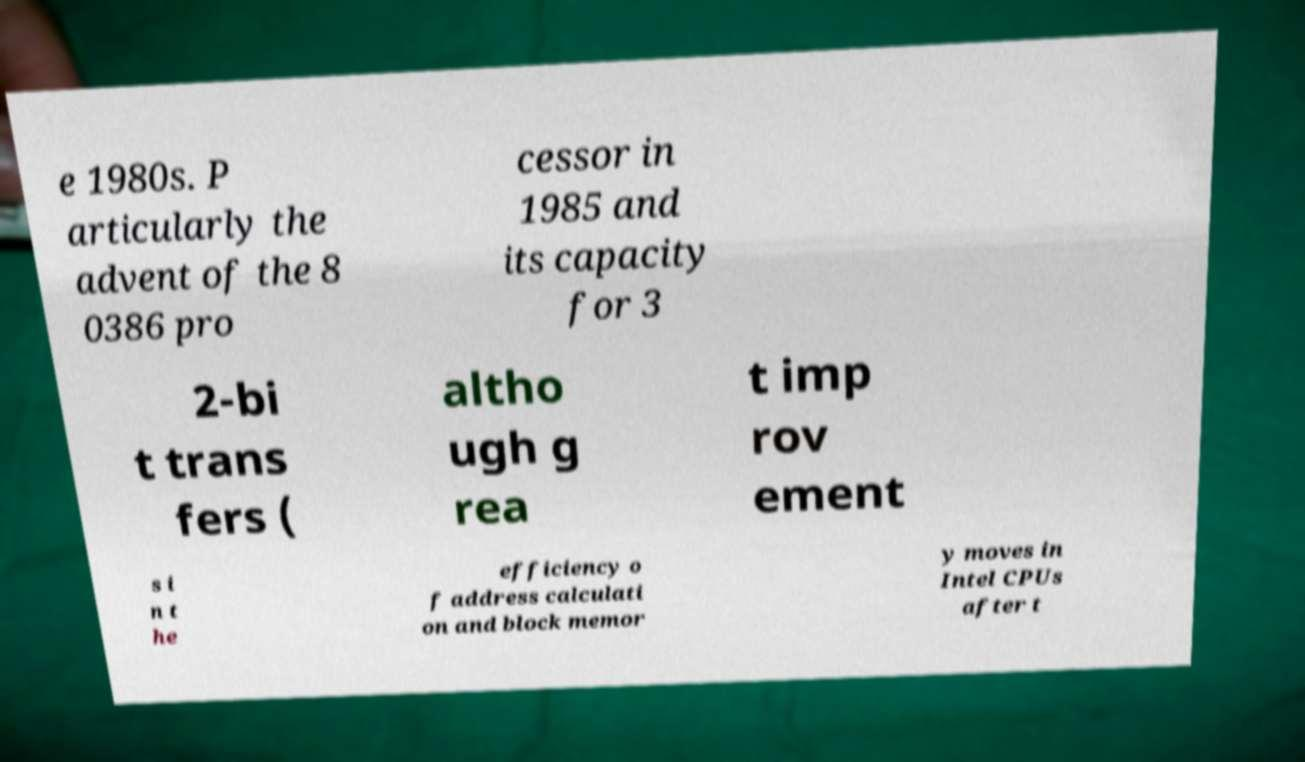I need the written content from this picture converted into text. Can you do that? e 1980s. P articularly the advent of the 8 0386 pro cessor in 1985 and its capacity for 3 2-bi t trans fers ( altho ugh g rea t imp rov ement s i n t he efficiency o f address calculati on and block memor y moves in Intel CPUs after t 